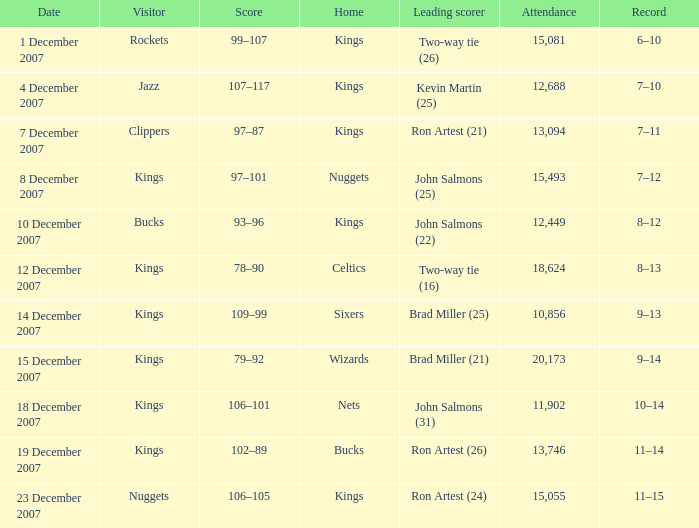What was the score of the match where the rockets were the away team? 6–10. 